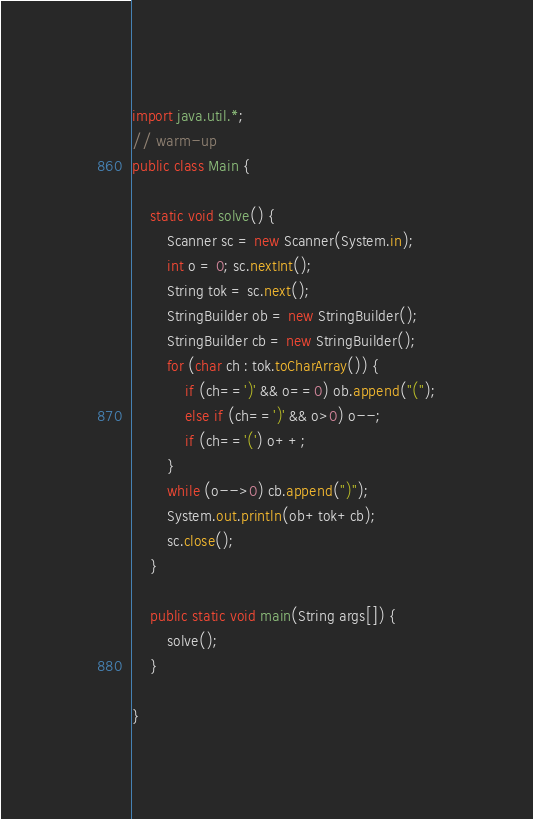<code> <loc_0><loc_0><loc_500><loc_500><_Java_>import java.util.*;
// warm-up
public class Main {

	static void solve() {
		Scanner sc = new Scanner(System.in);
		int o = 0; sc.nextInt();
		String tok = sc.next();
		StringBuilder ob = new StringBuilder();
		StringBuilder cb = new StringBuilder();
		for (char ch : tok.toCharArray()) {
			if (ch==')' && o==0) ob.append("(");
			else if (ch==')' && o>0) o--;
			if (ch=='(') o++;
		}
		while (o-->0) cb.append(")");
		System.out.println(ob+tok+cb);
		sc.close();		
	}

	public static void main(String args[]) {
		solve();
	}

}</code> 